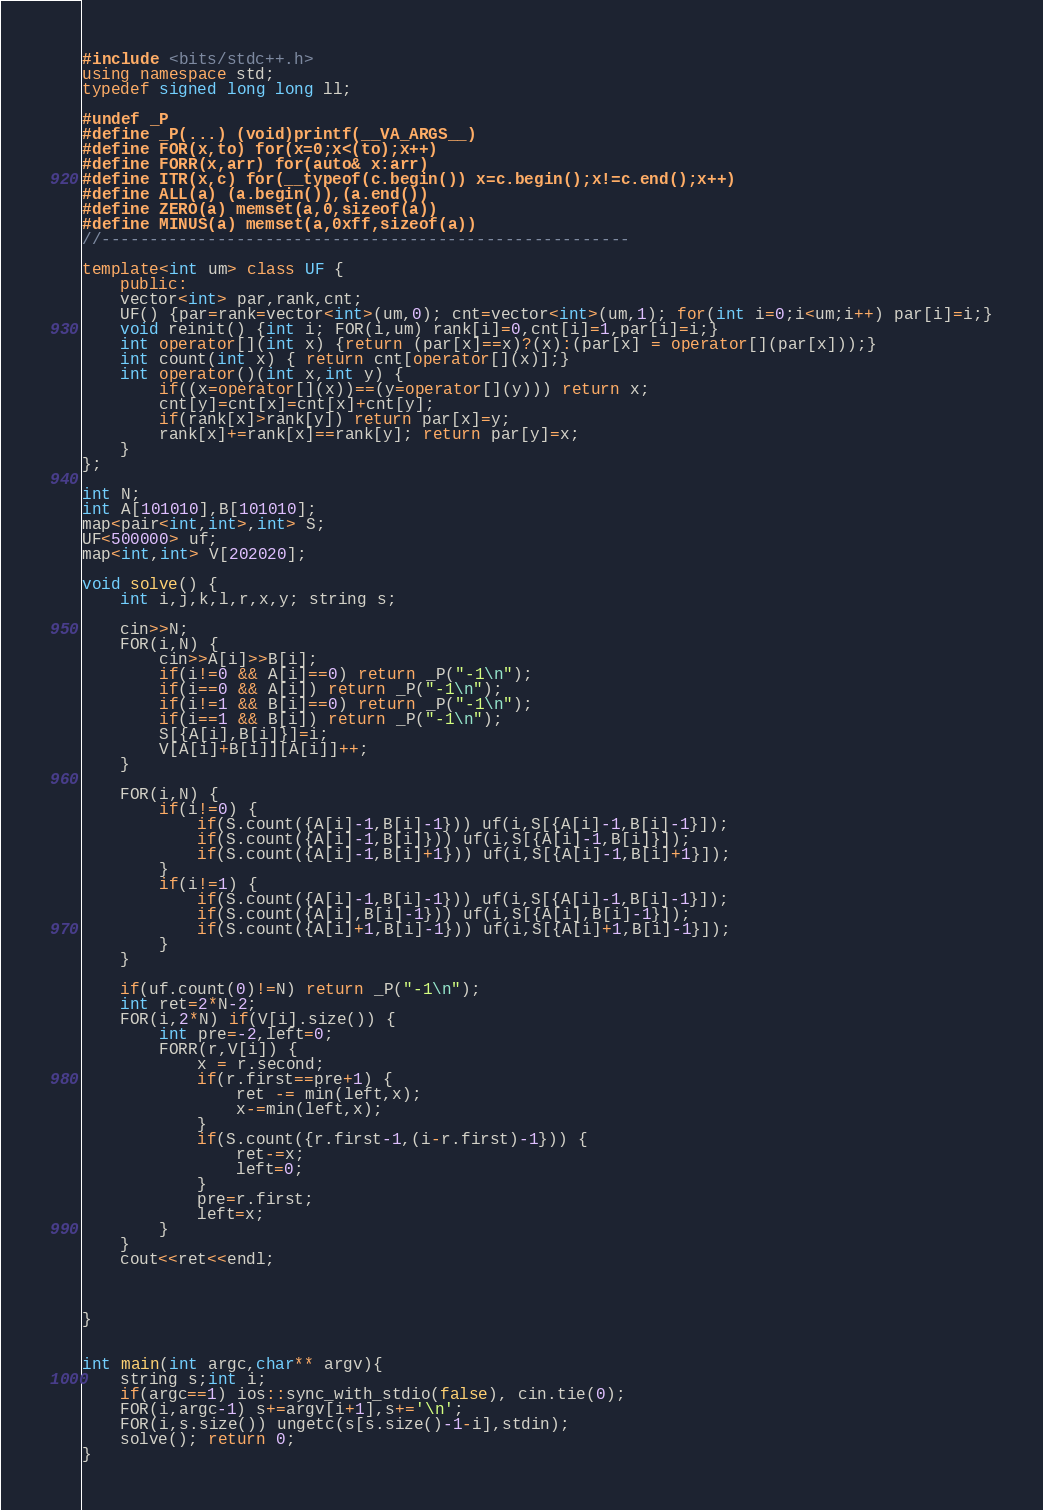<code> <loc_0><loc_0><loc_500><loc_500><_C++_>#include <bits/stdc++.h>
using namespace std;
typedef signed long long ll;

#undef _P
#define _P(...) (void)printf(__VA_ARGS__)
#define FOR(x,to) for(x=0;x<(to);x++)
#define FORR(x,arr) for(auto& x:arr)
#define ITR(x,c) for(__typeof(c.begin()) x=c.begin();x!=c.end();x++)
#define ALL(a) (a.begin()),(a.end())
#define ZERO(a) memset(a,0,sizeof(a))
#define MINUS(a) memset(a,0xff,sizeof(a))
//-------------------------------------------------------

template<int um> class UF {
	public:
	vector<int> par,rank,cnt;
	UF() {par=rank=vector<int>(um,0); cnt=vector<int>(um,1); for(int i=0;i<um;i++) par[i]=i;}
	void reinit() {int i; FOR(i,um) rank[i]=0,cnt[i]=1,par[i]=i;}
	int operator[](int x) {return (par[x]==x)?(x):(par[x] = operator[](par[x]));}
	int count(int x) { return cnt[operator[](x)];}
	int operator()(int x,int y) {
		if((x=operator[](x))==(y=operator[](y))) return x;
		cnt[y]=cnt[x]=cnt[x]+cnt[y];
		if(rank[x]>rank[y]) return par[x]=y;
		rank[x]+=rank[x]==rank[y]; return par[y]=x;
	}
};

int N;
int A[101010],B[101010];
map<pair<int,int>,int> S;
UF<500000> uf;
map<int,int> V[202020];

void solve() {
	int i,j,k,l,r,x,y; string s;
	
	cin>>N;
	FOR(i,N) {
		cin>>A[i]>>B[i];
		if(i!=0 && A[i]==0) return _P("-1\n");
		if(i==0 && A[i]) return _P("-1\n");
		if(i!=1 && B[i]==0) return _P("-1\n");
		if(i==1 && B[i]) return _P("-1\n");
		S[{A[i],B[i]}]=i;
		V[A[i]+B[i]][A[i]]++;
	}
	
	FOR(i,N) {
		if(i!=0) {
			if(S.count({A[i]-1,B[i]-1})) uf(i,S[{A[i]-1,B[i]-1}]);
			if(S.count({A[i]-1,B[i]})) uf(i,S[{A[i]-1,B[i]}]);
			if(S.count({A[i]-1,B[i]+1})) uf(i,S[{A[i]-1,B[i]+1}]);
		}
		if(i!=1) {
			if(S.count({A[i]-1,B[i]-1})) uf(i,S[{A[i]-1,B[i]-1}]);
			if(S.count({A[i],B[i]-1})) uf(i,S[{A[i],B[i]-1}]);
			if(S.count({A[i]+1,B[i]-1})) uf(i,S[{A[i]+1,B[i]-1}]);
		}
	}
	
	if(uf.count(0)!=N) return _P("-1\n");
	int ret=2*N-2;
	FOR(i,2*N) if(V[i].size()) {
		int pre=-2,left=0;
		FORR(r,V[i]) {
			x = r.second;
			if(r.first==pre+1) {
				ret -= min(left,x);
				x-=min(left,x);
			}
			if(S.count({r.first-1,(i-r.first)-1})) {
				ret-=x;
				left=0;
			}
			pre=r.first;
			left=x;
		}
	}
	cout<<ret<<endl;
	
	
	
}


int main(int argc,char** argv){
	string s;int i;
	if(argc==1) ios::sync_with_stdio(false), cin.tie(0);
	FOR(i,argc-1) s+=argv[i+1],s+='\n';
	FOR(i,s.size()) ungetc(s[s.size()-1-i],stdin);
	solve(); return 0;
}
</code> 